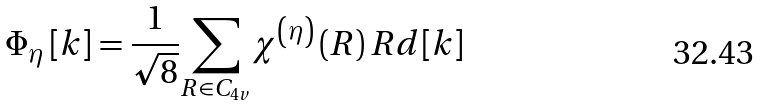Convert formula to latex. <formula><loc_0><loc_0><loc_500><loc_500>\Phi _ { \eta } \left [ k \right ] = \frac { 1 } { \sqrt { 8 } } { \sum _ { R \in C _ { 4 v } } } \chi ^ { \left ( \eta \right ) } \left ( R \right ) R d [ k ]</formula> 